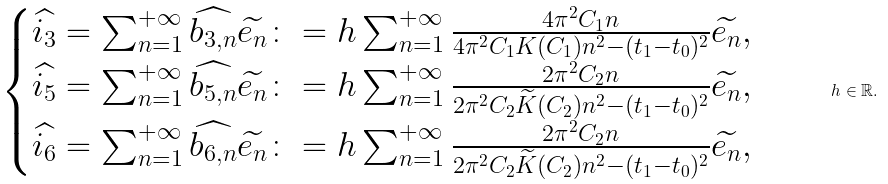<formula> <loc_0><loc_0><loc_500><loc_500>\begin{array} { r c l } \begin{cases} \widehat { i _ { 3 } } = \sum _ { n = 1 } ^ { + \infty } \widehat { b _ { 3 , n } } \widetilde { e _ { n } } \colon = h \sum _ { n = 1 } ^ { + \infty } \frac { 4 \pi ^ { 2 } C _ { 1 } n } { 4 \pi ^ { 2 } C _ { 1 } K ( C _ { 1 } ) n ^ { 2 } - ( t _ { 1 } - t _ { 0 } ) ^ { 2 } } \widetilde { e _ { n } } , \\ \widehat { i _ { 5 } } = \sum _ { n = 1 } ^ { + \infty } \widehat { b _ { 5 , n } } \widetilde { e _ { n } } \colon = h \sum _ { n = 1 } ^ { + \infty } \frac { 2 \pi ^ { 2 } C _ { 2 } n } { 2 \pi ^ { 2 } C _ { 2 } \widetilde { K } ( C _ { 2 } ) n ^ { 2 } - ( t _ { 1 } - t _ { 0 } ) ^ { 2 } } \widetilde { e _ { n } } , \\ \widehat { i _ { 6 } } = \sum _ { n = 1 } ^ { + \infty } \widehat { b _ { 6 , n } } \widetilde { e _ { n } } \colon = h \sum _ { n = 1 } ^ { + \infty } \frac { 2 \pi ^ { 2 } C _ { 2 } n } { 2 \pi ^ { 2 } C _ { 2 } \widetilde { K } ( C _ { 2 } ) n ^ { 2 } - ( t _ { 1 } - t _ { 0 } ) ^ { 2 } } \widetilde { e _ { n } } , \end{cases} \end{array} \quad h \in \mathbb { R } .</formula> 